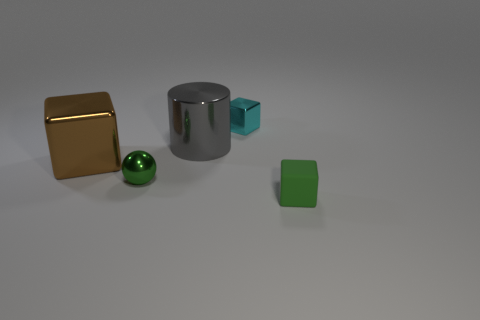How do the textures of the objects differ? The golden cube has a smooth, perhaps metallic texture indicative of polish or luster, while the green rubber cube appears to have a matte, slightly rough texture. The chrome cylinder shows a reflective surface, mirroring its environment faintly on its side, and the green sphere seems to have a polished yet not reflective surface, hinting at a sleek, perhaps coated rubbery texture. 